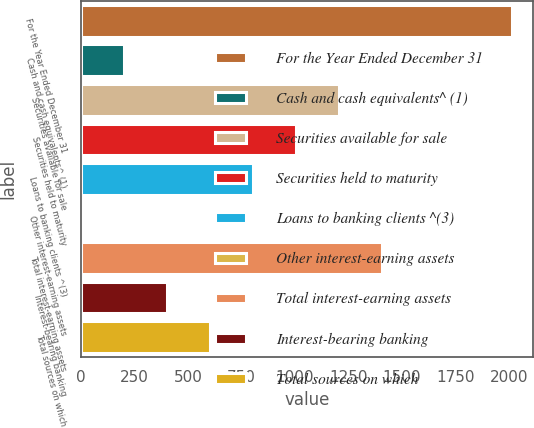Convert chart to OTSL. <chart><loc_0><loc_0><loc_500><loc_500><bar_chart><fcel>For the Year Ended December 31<fcel>Cash and cash equivalents^ (1)<fcel>Securities available for sale<fcel>Securities held to maturity<fcel>Loans to banking clients ^(3)<fcel>Other interest-earning assets<fcel>Total interest-earning assets<fcel>Interest-bearing banking<fcel>Total sources on which<nl><fcel>2012<fcel>202.1<fcel>1207.6<fcel>1006.5<fcel>805.4<fcel>1<fcel>1408.7<fcel>403.2<fcel>604.3<nl></chart> 